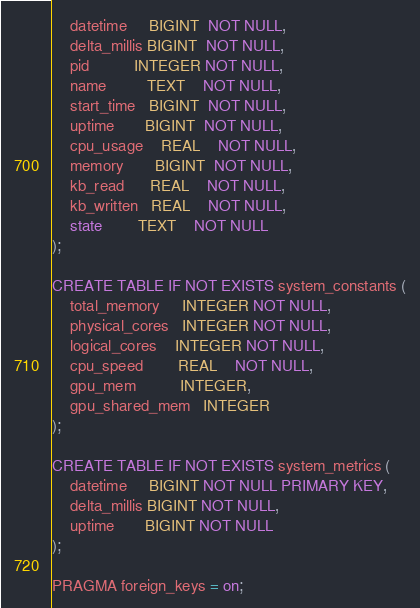<code> <loc_0><loc_0><loc_500><loc_500><_SQL_>    datetime     BIGINT  NOT NULL,
    delta_millis BIGINT  NOT NULL,
    pid          INTEGER NOT NULL,
    name         TEXT    NOT NULL,
    start_time   BIGINT  NOT NULL,
    uptime       BIGINT  NOT NULL,
    cpu_usage    REAL    NOT NULL,
    memory       BIGINT  NOT NULL,
    kb_read      REAL    NOT NULL,
    kb_written   REAL    NOT NULL,
    state        TEXT    NOT NULL
);

CREATE TABLE IF NOT EXISTS system_constants (
    total_memory     INTEGER NOT NULL,
    physical_cores   INTEGER NOT NULL,
    logical_cores    INTEGER NOT NULL,
    cpu_speed        REAL    NOT NULL,
    gpu_mem          INTEGER,
    gpu_shared_mem   INTEGER
);

CREATE TABLE IF NOT EXISTS system_metrics (
    datetime     BIGINT NOT NULL PRIMARY KEY,
    delta_millis BIGINT NOT NULL,
    uptime       BIGINT NOT NULL
);

PRAGMA foreign_keys = on;
</code> 